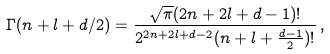Convert formula to latex. <formula><loc_0><loc_0><loc_500><loc_500>\Gamma ( n + l + d / 2 ) = \frac { \sqrt { \pi } ( 2 n + 2 l + d - 1 ) ! } { 2 ^ { 2 n + 2 l + d - 2 } ( n + l + \frac { d - 1 } { 2 } ) ! } \, ,</formula> 